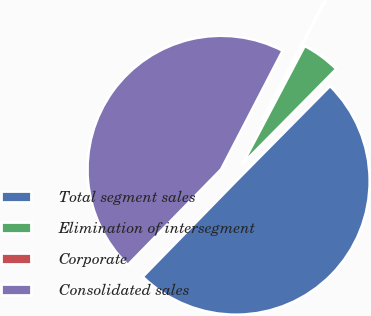Convert chart. <chart><loc_0><loc_0><loc_500><loc_500><pie_chart><fcel>Total segment sales<fcel>Elimination of intersegment<fcel>Corporate<fcel>Consolidated sales<nl><fcel>49.9%<fcel>4.69%<fcel>0.1%<fcel>45.31%<nl></chart> 